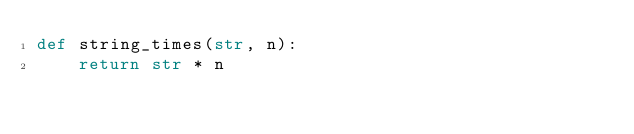Convert code to text. <code><loc_0><loc_0><loc_500><loc_500><_Python_>def string_times(str, n):
    return str * n
</code> 